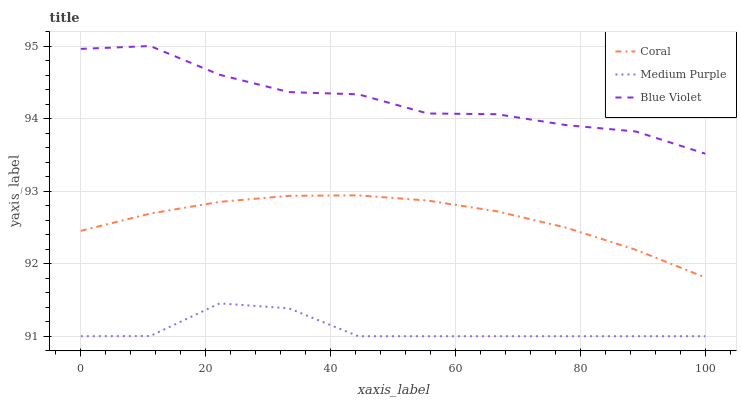Does Medium Purple have the minimum area under the curve?
Answer yes or no. Yes. Does Blue Violet have the maximum area under the curve?
Answer yes or no. Yes. Does Coral have the minimum area under the curve?
Answer yes or no. No. Does Coral have the maximum area under the curve?
Answer yes or no. No. Is Coral the smoothest?
Answer yes or no. Yes. Is Blue Violet the roughest?
Answer yes or no. Yes. Is Blue Violet the smoothest?
Answer yes or no. No. Is Coral the roughest?
Answer yes or no. No. Does Coral have the lowest value?
Answer yes or no. No. Does Blue Violet have the highest value?
Answer yes or no. Yes. Does Coral have the highest value?
Answer yes or no. No. Is Medium Purple less than Coral?
Answer yes or no. Yes. Is Blue Violet greater than Coral?
Answer yes or no. Yes. Does Medium Purple intersect Coral?
Answer yes or no. No. 